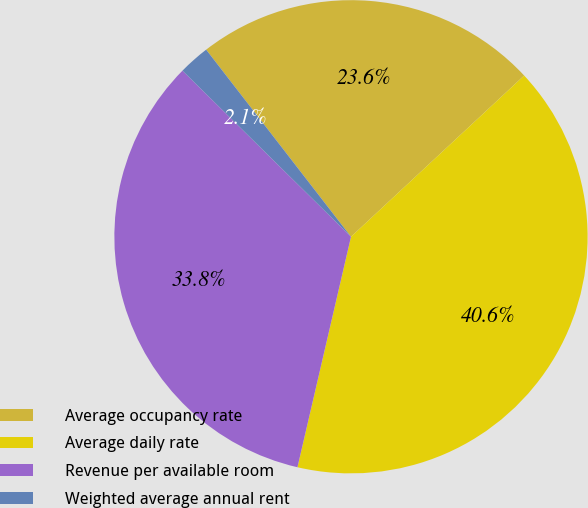<chart> <loc_0><loc_0><loc_500><loc_500><pie_chart><fcel>Average occupancy rate<fcel>Average daily rate<fcel>Revenue per available room<fcel>Weighted average annual rent<nl><fcel>23.55%<fcel>40.56%<fcel>33.75%<fcel>2.13%<nl></chart> 